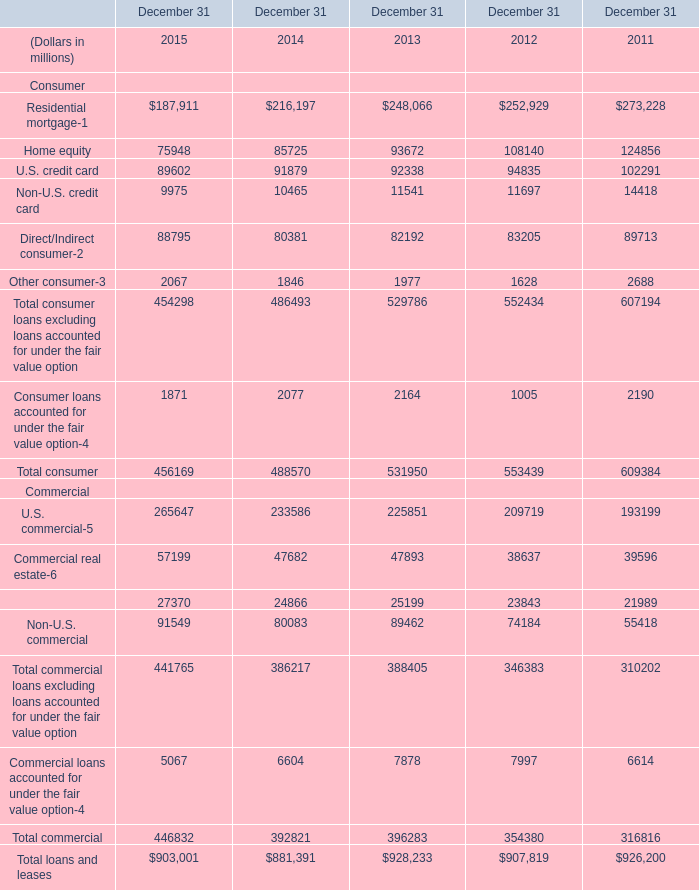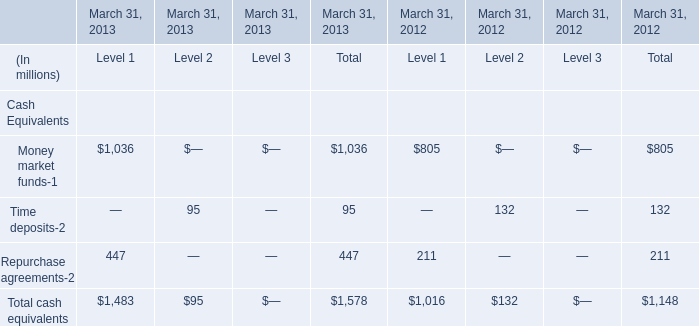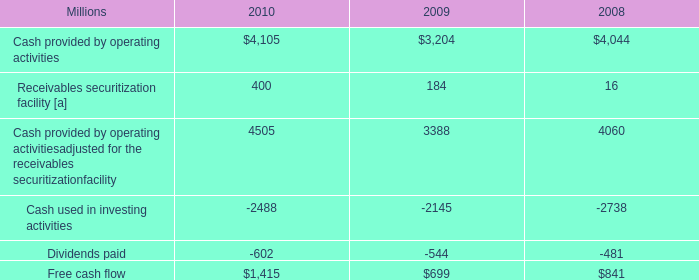What is the growing rate of Total commercial in the years with the least Total consumer? 
Computations: ((446832 - 392821) / 392821)
Answer: 0.1375. 